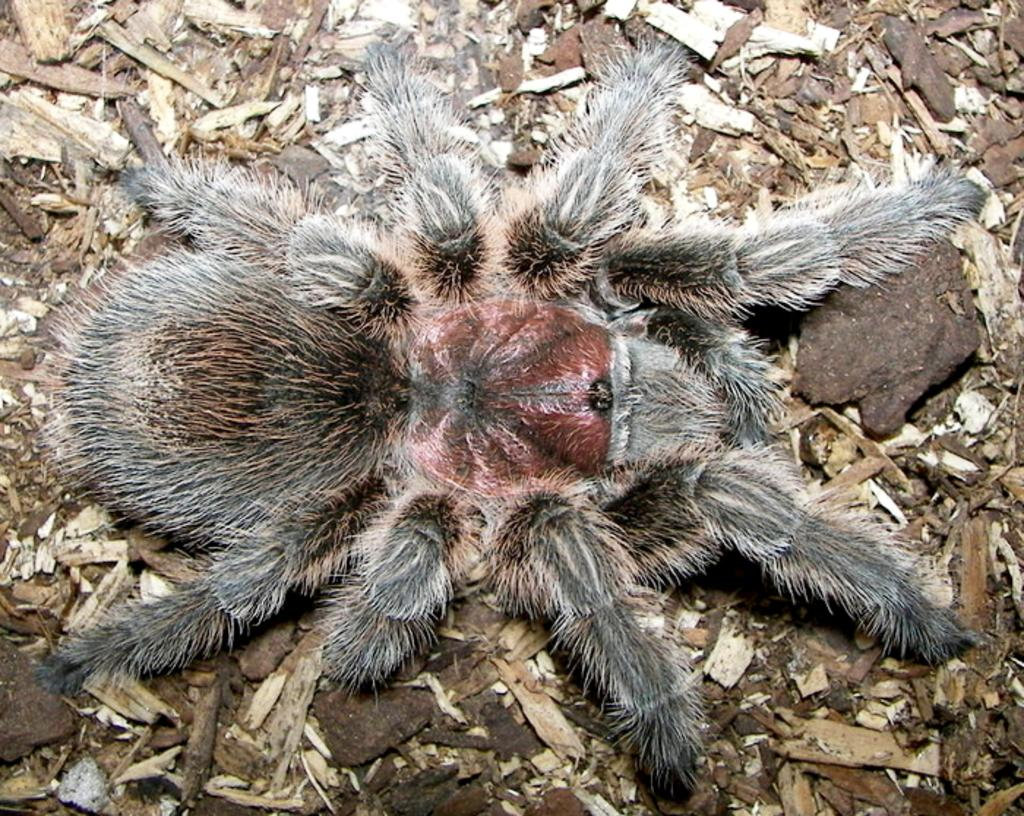What is the main subject of the image? The main subject of the image is a spider. What is the spider resting on? The spider is on wooden particles. What type of pencil can be seen in the image? There is no pencil present in the image; it features a spider on wooden particles. Can you tell me how many kitties are visible in the image? There are no kitties present in the image. 